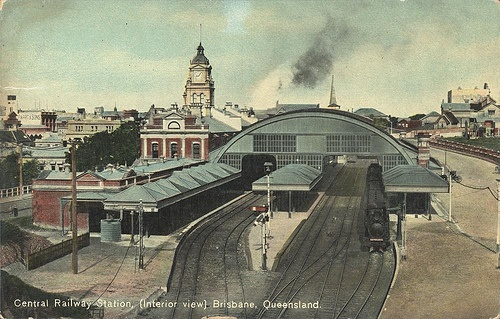Describe the objects in this image and their specific colors. I can see train in tan, black, and gray tones and clock in tan and beige tones in this image. 